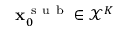Convert formula to latex. <formula><loc_0><loc_0><loc_500><loc_500>x _ { 0 } ^ { s u b } \in \mathcal { X } ^ { K }</formula> 